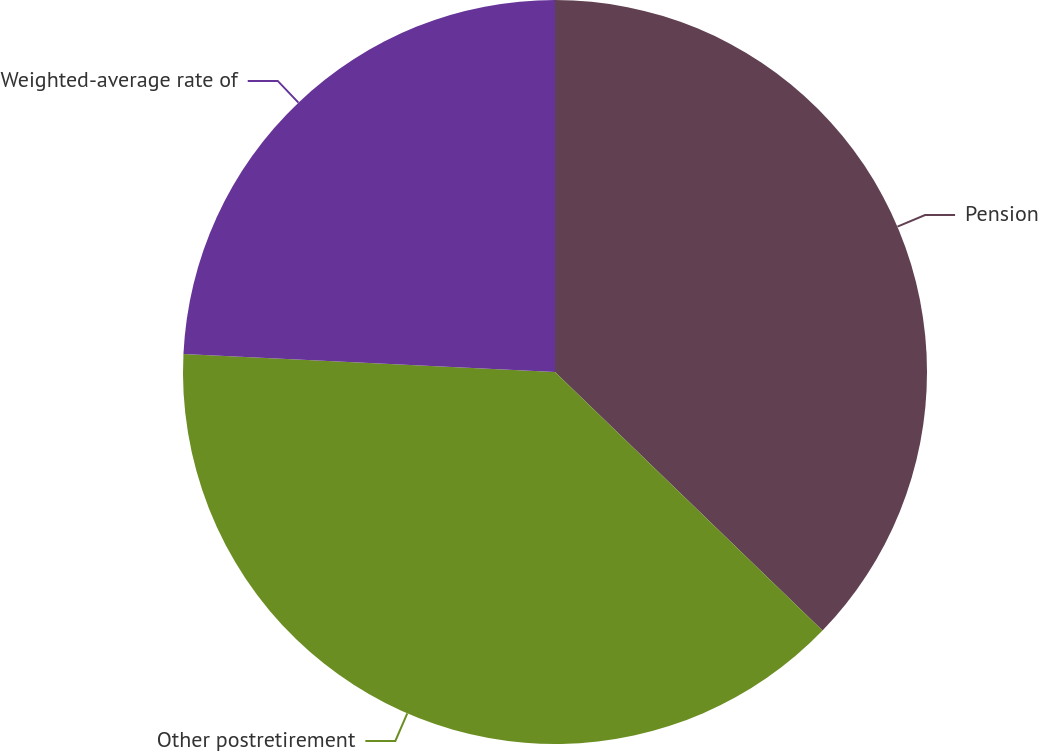Convert chart. <chart><loc_0><loc_0><loc_500><loc_500><pie_chart><fcel>Pension<fcel>Other postretirement<fcel>Weighted-average rate of<nl><fcel>37.23%<fcel>38.55%<fcel>24.23%<nl></chart> 